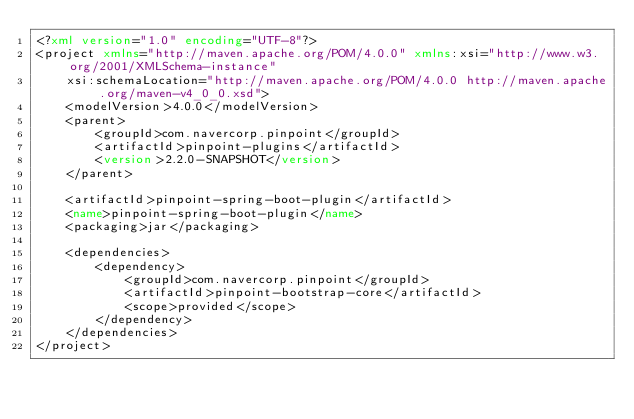<code> <loc_0><loc_0><loc_500><loc_500><_XML_><?xml version="1.0" encoding="UTF-8"?>
<project xmlns="http://maven.apache.org/POM/4.0.0" xmlns:xsi="http://www.w3.org/2001/XMLSchema-instance"
    xsi:schemaLocation="http://maven.apache.org/POM/4.0.0 http://maven.apache.org/maven-v4_0_0.xsd">
    <modelVersion>4.0.0</modelVersion>
    <parent>
        <groupId>com.navercorp.pinpoint</groupId>
        <artifactId>pinpoint-plugins</artifactId>
        <version>2.2.0-SNAPSHOT</version>
    </parent>

    <artifactId>pinpoint-spring-boot-plugin</artifactId>
    <name>pinpoint-spring-boot-plugin</name>
    <packaging>jar</packaging>

    <dependencies>
        <dependency>
            <groupId>com.navercorp.pinpoint</groupId>
            <artifactId>pinpoint-bootstrap-core</artifactId>
            <scope>provided</scope>
        </dependency>
    </dependencies>
</project></code> 